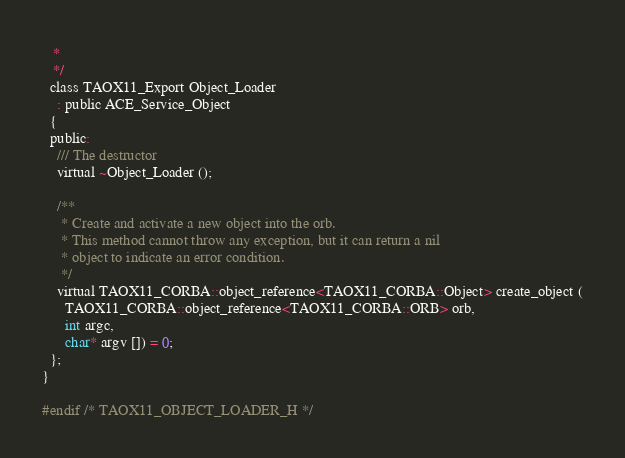<code> <loc_0><loc_0><loc_500><loc_500><_C_>   *
   */
  class TAOX11_Export Object_Loader
    : public ACE_Service_Object
  {
  public:
    /// The destructor
    virtual ~Object_Loader ();

    /**
     * Create and activate a new object into the orb.
     * This method cannot throw any exception, but it can return a nil
     * object to indicate an error condition.
     */
    virtual TAOX11_CORBA::object_reference<TAOX11_CORBA::Object> create_object (
      TAOX11_CORBA::object_reference<TAOX11_CORBA::ORB> orb,
      int argc,
      char* argv []) = 0;
  };
}

#endif /* TAOX11_OBJECT_LOADER_H */
</code> 